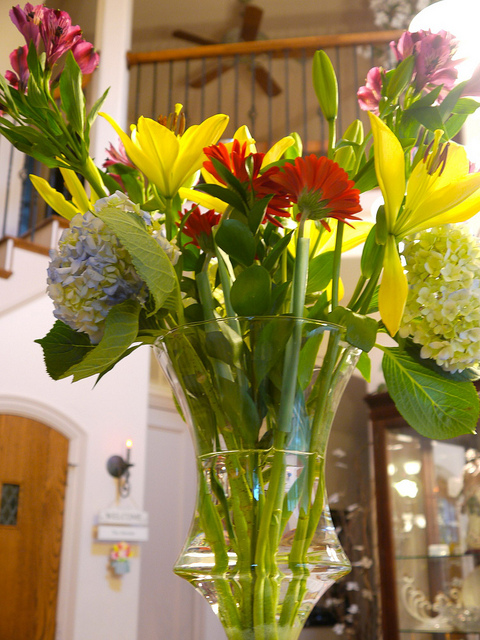<image>What kind of fan? I am not sure what kind of fan it is. However, it can be a ceiling fan. What kind of fan? I am not sure what kind of fan it is. It can be a ceiling fan. 